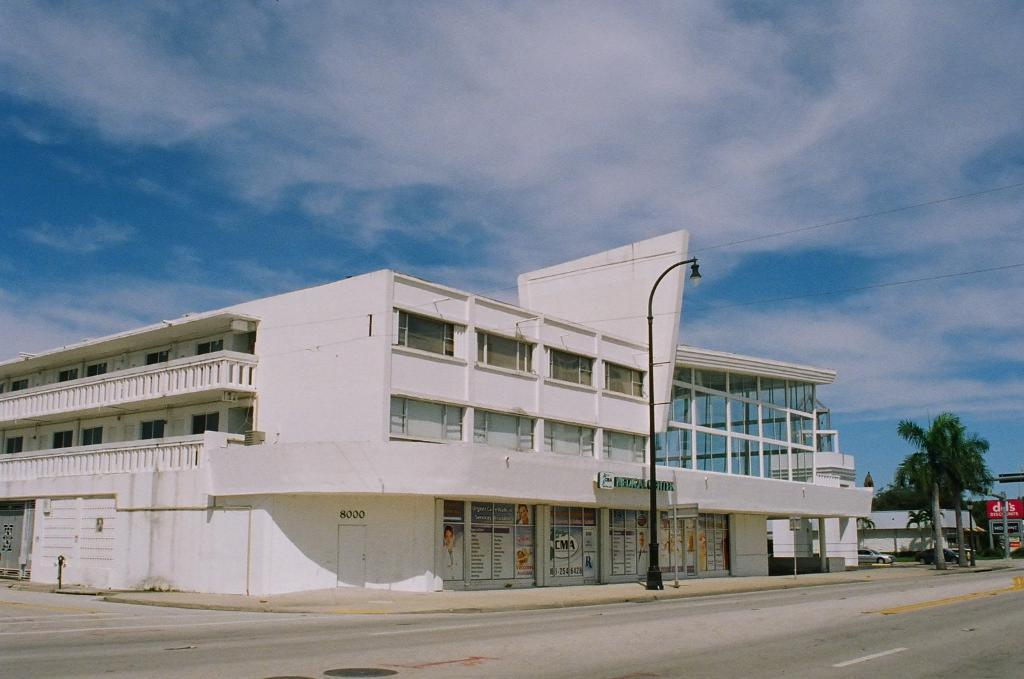What type of structure can be seen in the image? There is a building and a house in the image. What can be found in the surroundings of the structures? There are trees, poles, street lights, banners, walls, windows, and a door visible in the image. What is at the bottom of the image? There is a road at the bottom of the image. What is visible in the background of the image? The sky is visible in the background of the image. What type of meal is being served in the image? There is no meal present in the image; it features a building, a house, and other elements mentioned in the conversation. Is there a prison visible in the image? No, there is no prison present in the image. 